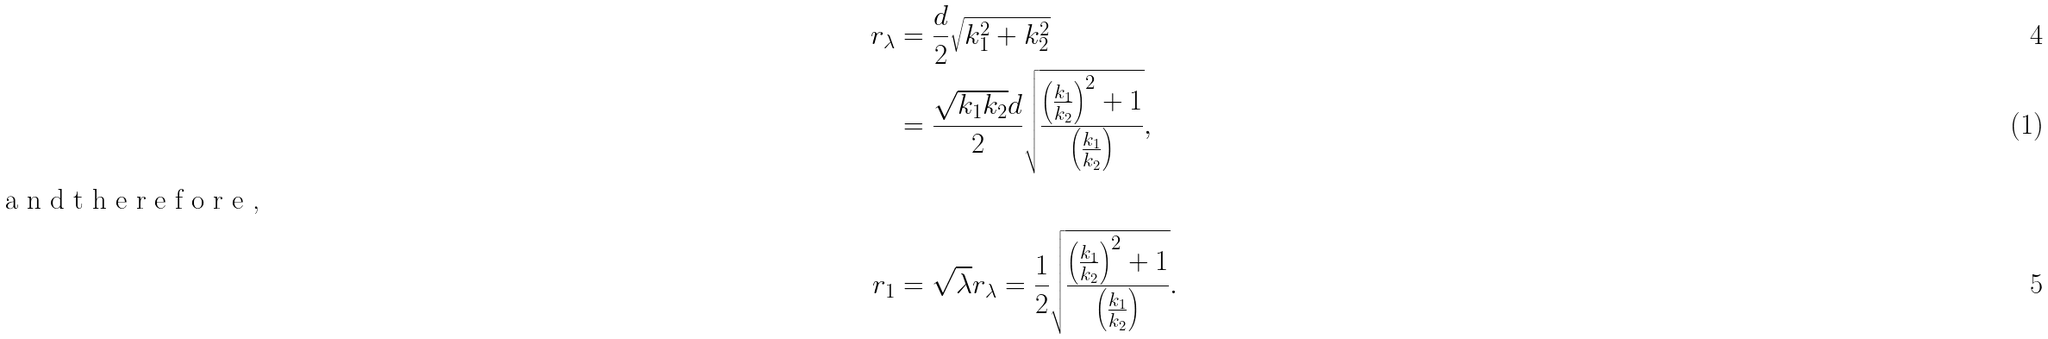<formula> <loc_0><loc_0><loc_500><loc_500>r _ { \lambda } & = \frac { d } { 2 } \sqrt { k _ { 1 } ^ { 2 } + k _ { 2 } ^ { 2 } } \\ & = \frac { \sqrt { k _ { 1 } k _ { 2 } } d } { 2 } \sqrt { \frac { \left ( \frac { k _ { 1 } } { k _ { 2 } } \right ) ^ { 2 } + 1 } { \left ( \frac { k _ { 1 } } { k _ { 2 } } \right ) } } , \intertext { a n d t h e r e f o r e , } r _ { 1 } & = \sqrt { \lambda } r _ { \lambda } = \frac { 1 } { 2 } \sqrt { \frac { \left ( \frac { k _ { 1 } } { k _ { 2 } } \right ) ^ { 2 } + 1 } { \left ( \frac { k _ { 1 } } { k _ { 2 } } \right ) } } .</formula> 